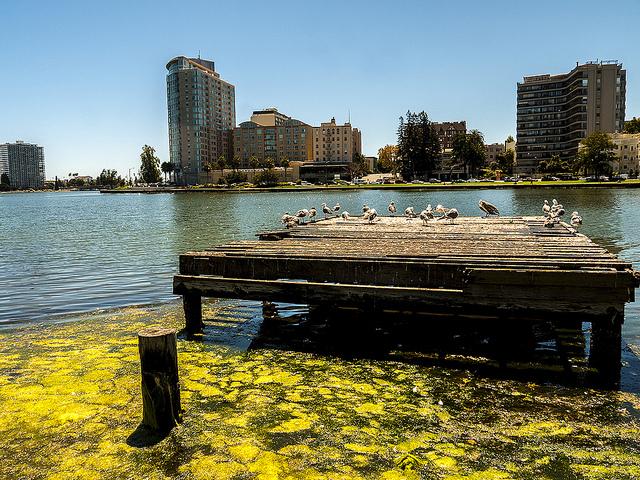What are the birds standing on?
Quick response, please. Dock. Is the water yellow?
Answer briefly. Yes. What is in the distant coast?
Keep it brief. Buildings. 